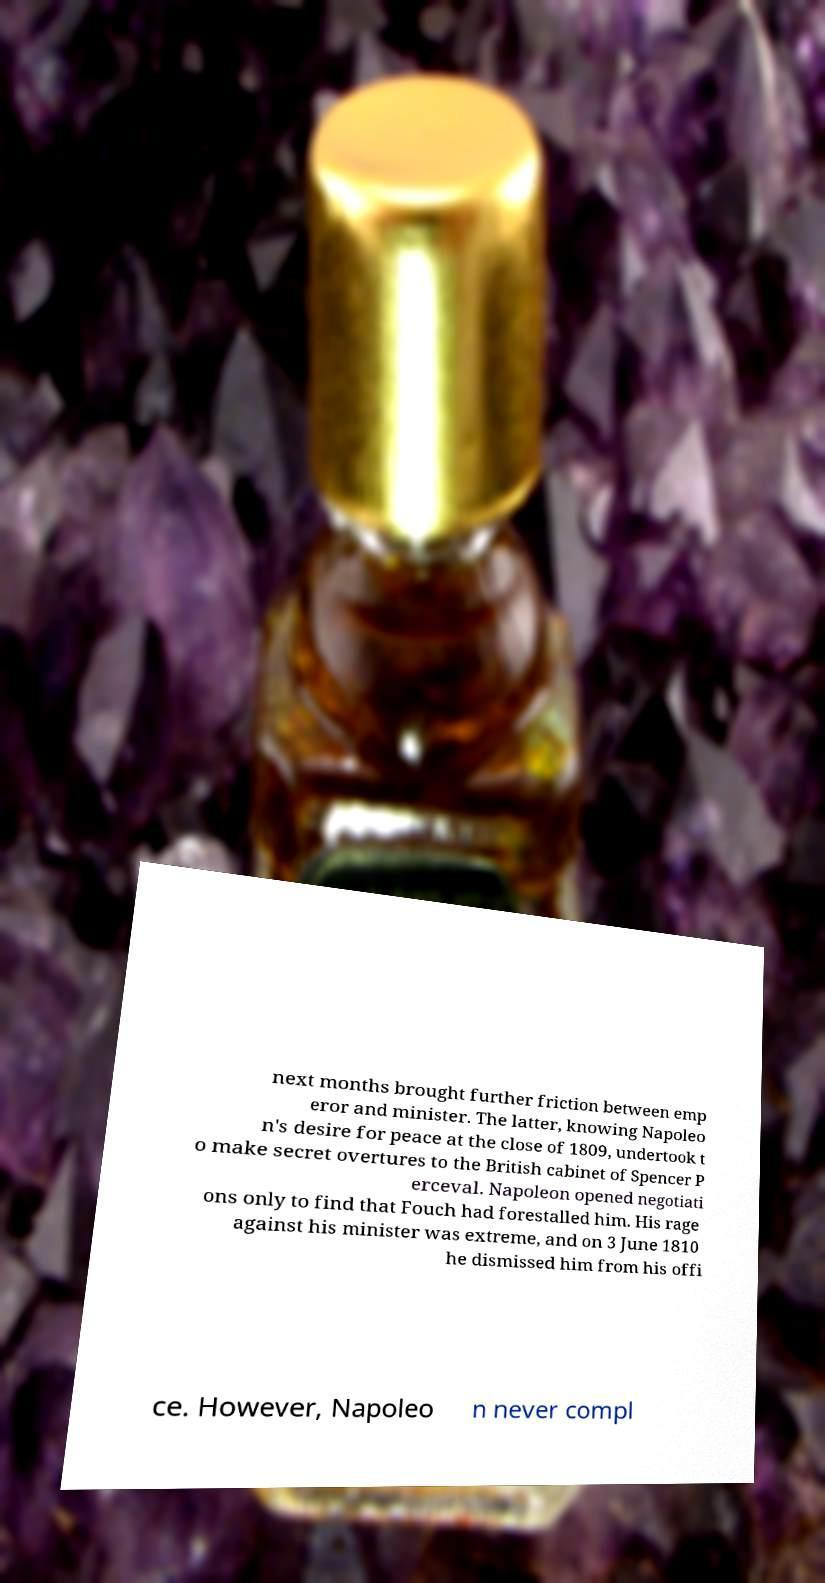I need the written content from this picture converted into text. Can you do that? next months brought further friction between emp eror and minister. The latter, knowing Napoleo n's desire for peace at the close of 1809, undertook t o make secret overtures to the British cabinet of Spencer P erceval. Napoleon opened negotiati ons only to find that Fouch had forestalled him. His rage against his minister was extreme, and on 3 June 1810 he dismissed him from his offi ce. However, Napoleo n never compl 